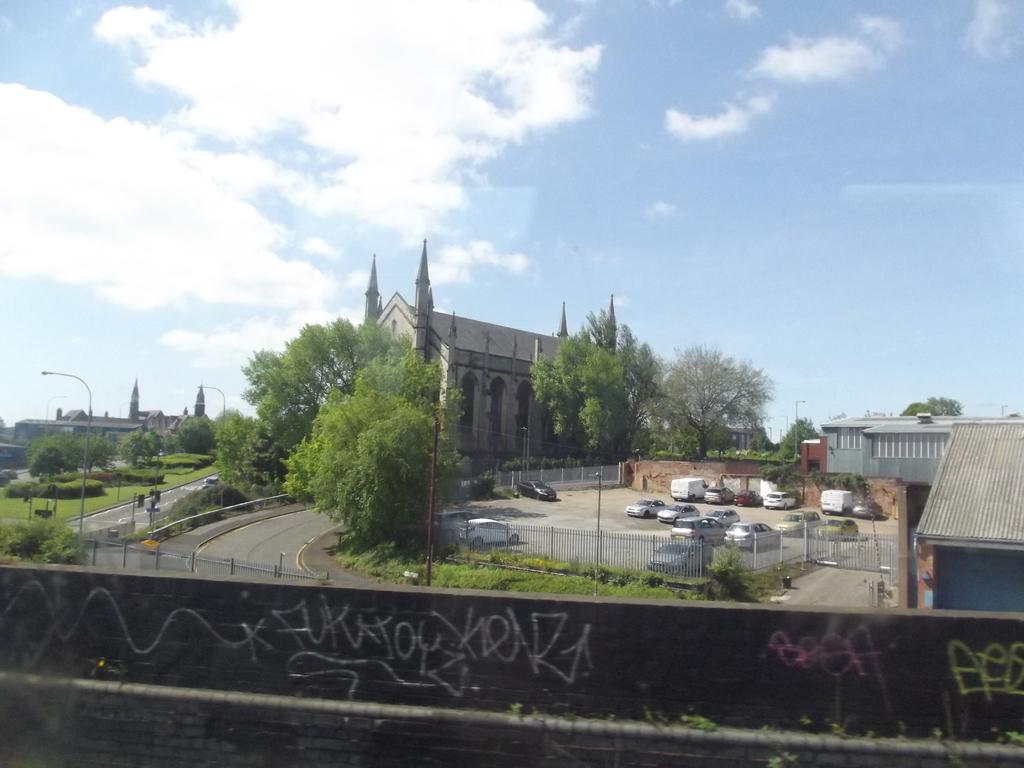<image>
Offer a succinct explanation of the picture presented. Cement wall in front of a church that has KAKAJOYXRNRA scribbled acrossed it. 